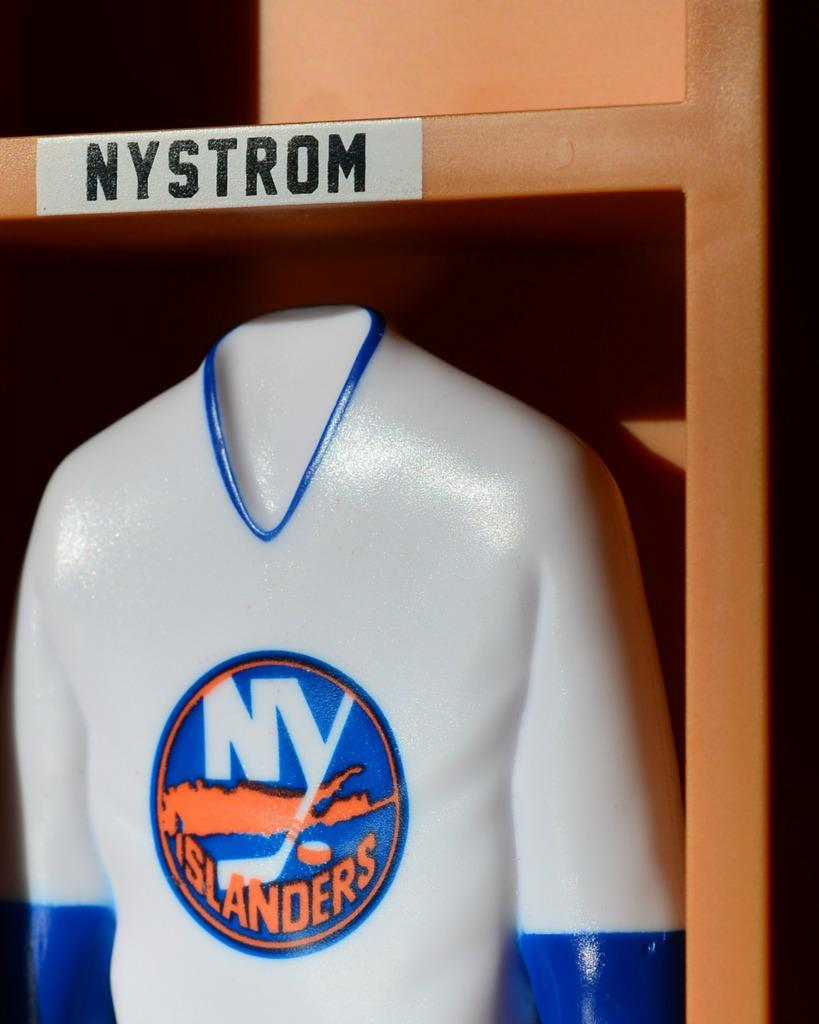<image>
Provide a brief description of the given image. a jersey that has NY Islanders written on it 